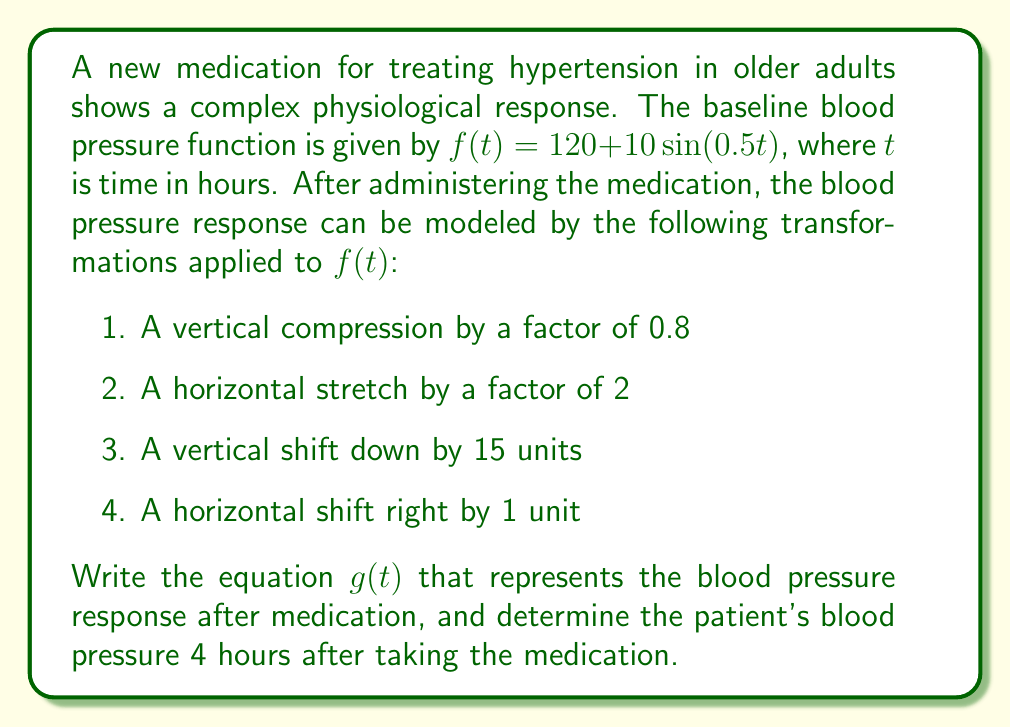Provide a solution to this math problem. Let's apply the transformations step by step:

1. Vertical compression by a factor of 0.8:
   $0.8f(t) = 0.8(120 + 10\sin(0.5t)) = 96 + 8\sin(0.5t)$

2. Horizontal stretch by a factor of 2:
   $96 + 8\sin(0.5(\frac{t}{2})) = 96 + 8\sin(0.25t)$

3. Vertical shift down by 15 units:
   $96 + 8\sin(0.25t) - 15 = 81 + 8\sin(0.25t)$

4. Horizontal shift right by 1 unit:
   $g(t) = 81 + 8\sin(0.25(t-1))$

Now that we have the equation for $g(t)$, let's calculate the blood pressure 4 hours after taking the medication:

$g(4) = 81 + 8\sin(0.25(4-1))$
$= 81 + 8\sin(0.75)$
$= 81 + 8(0.6816)$ (using a calculator or trigonometric table)
$= 81 + 5.4528$
$= 86.4528$

Rounding to the nearest whole number, as blood pressure is typically measured in whole numbers:

$g(4) \approx 86$ mmHg
Answer: $g(t) = 81 + 8\sin(0.25(t-1))$; 86 mmHg 